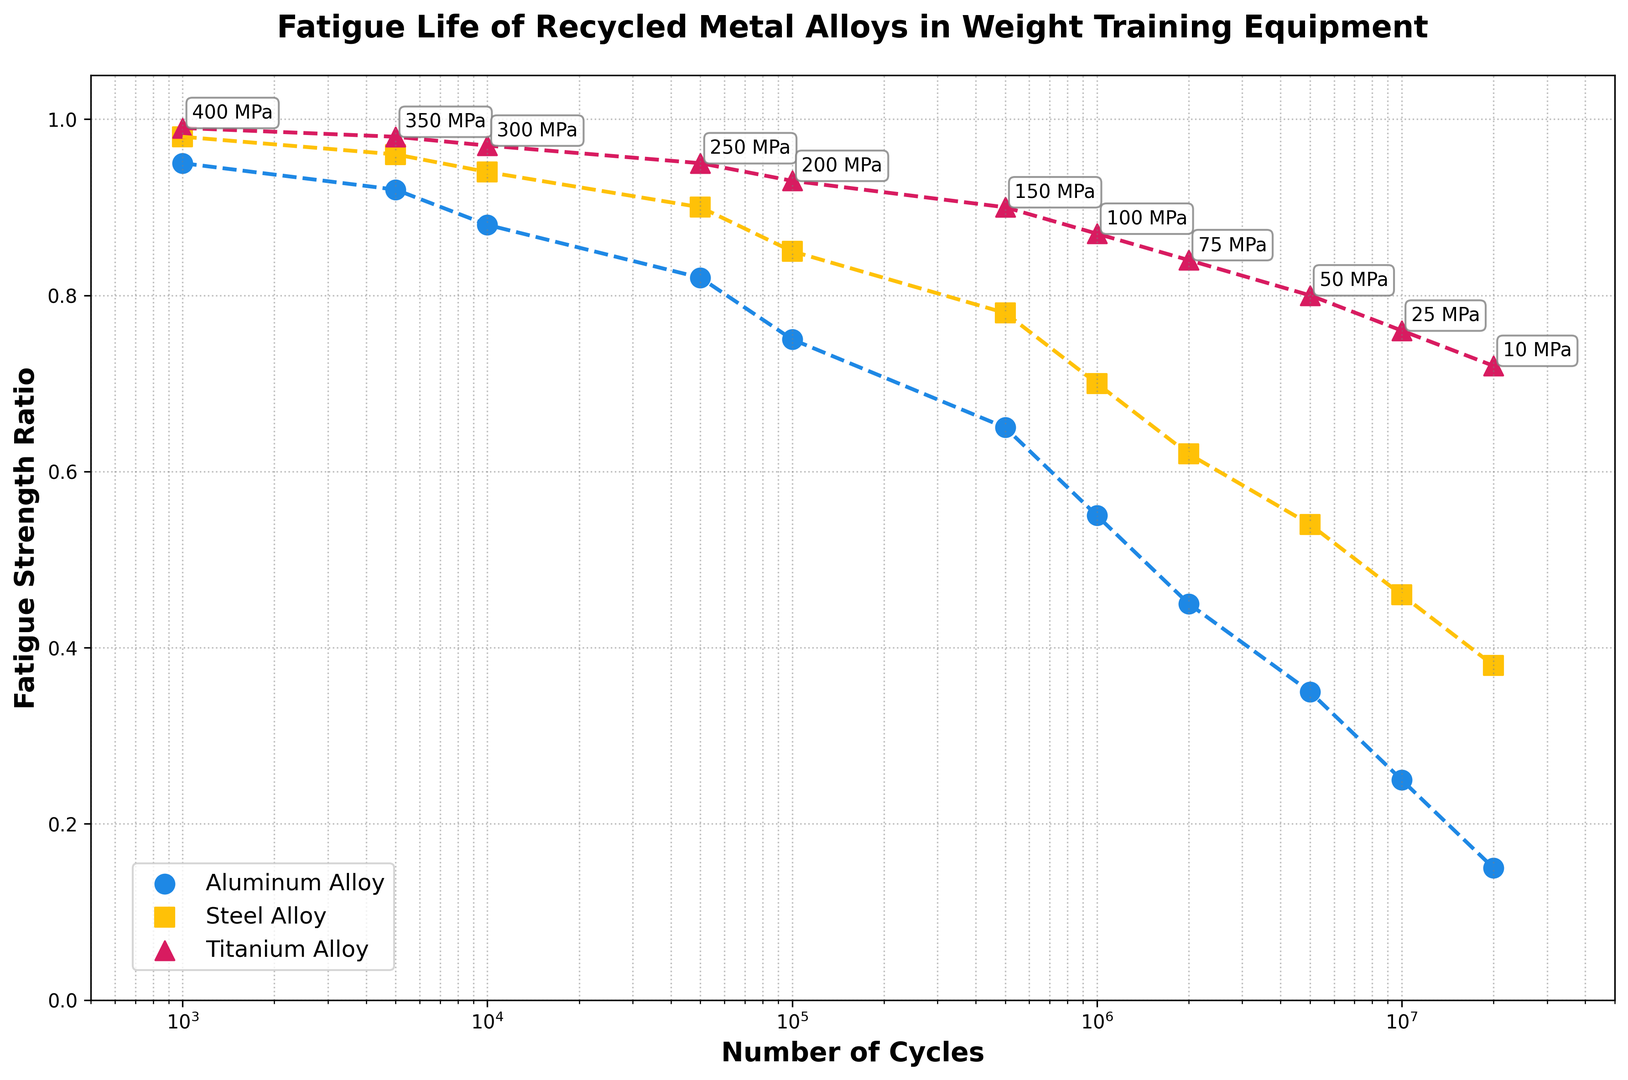What's the fatigue strength ratio of Steel Alloy at 500,000 cycles? Look at the point where 'Cycles' is 500,000 on the x-axis. The corresponding 'Steel Alloy' value is about 0.78
Answer: 0.78 Which alloy retains the highest fatigue strength ratio at 10,000,000 cycles? Look at the points where 'Cycles' is 10,000,000 on the x-axis. The highest 'Fatigue Strength Ratio' among Aluminum Alloy, Steel Alloy, and Titanium Alloy is 0.76 for Titanium Alloy
Answer: Titanium Alloy What is the difference in fatigue strength ratio between Aluminum Alloy and Steel Alloy at 100,000 cycles? Find the fatigue strength ratios for both alloys at 100,000 cycles. Aluminum Alloy has 0.75 and Steel Alloy has 0.85. The difference is 0.85 - 0.75
Answer: 0.10 At which cycle count does the fatigue strength ratio of Aluminum Alloy first drop below 0.50? Locate where the 'Aluminum Alloy' line first falls below 0.50 on the y-axis. This occurs at approximately 2,000,000 cycles
Answer: 2,000,000 cycles How do the stress levels labeled on the plot change as the number of cycles increases? The stress levels labeled on the plot decrease as the number of cycles increases, from 400 MPa at 1,000 cycles to 10 MPa at 20,000,000 cycles. This decrease is consistent across the range of cycles
Answer: They decrease Is the decline in fatigue strength ratio steeper for Aluminum Alloy or Steel Alloy from 100,000 to 1,000,000 cycles? Compare the slopes of the lines for Aluminum Alloy and Steel Alloy between 100,000 and 1,000,000 cycles. The Aluminum Alloy declines from 0.75 to 0.55, a drop of 0.20, whereas Steel Alloy declines from 0.85 to 0.70, a drop of 0.15. The decline is steeper for Aluminum Alloy
Answer: Aluminum Alloy What is the average fatigue strength ratio of Titanium Alloy at 1,000, 100,000, and 10,000,000 cycles? Find the values of 'Titanium Alloy' at 1,000, 100,000, and 10,000,000 cycles, which are 0.99, 0.93, and 0.76. Calculate the average: (0.99 + 0.93 + 0.76) / 3
Answer: 0.89 How much lower is the stress level at 5,000,000 cycles compared to 1,000,000 cycles? Look at the stress levels labeled for both points. At 5,000,000 cycles, it is 50 MPa, and at 1,000,000 cycles, it is 100 MPa. The difference is 100 MPa - 50 MPa
Answer: 50 MPa 